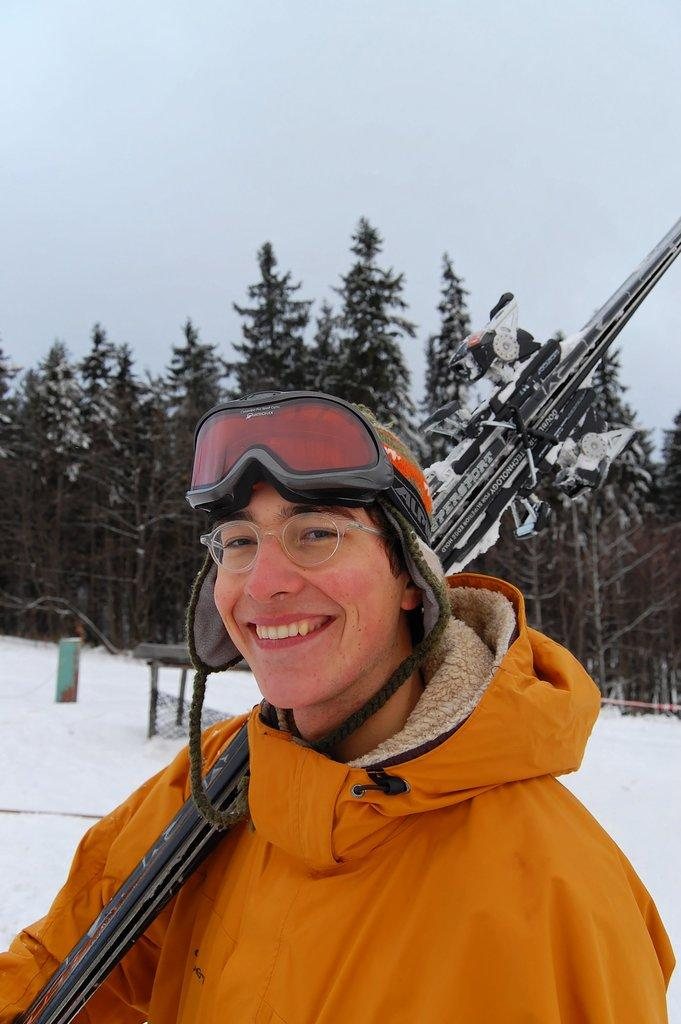Who is present in the image? There is a person in the image. What is the person doing in the image? The person is smiling and holding a ski board. What can be seen in the background of the image? There are trees, snow, and the sky visible in the background of the image. What type of calendar is hanging on the wall in the image? There is no calendar present in the image. Can you see any cars in the image? There are no cars visible in the image. 